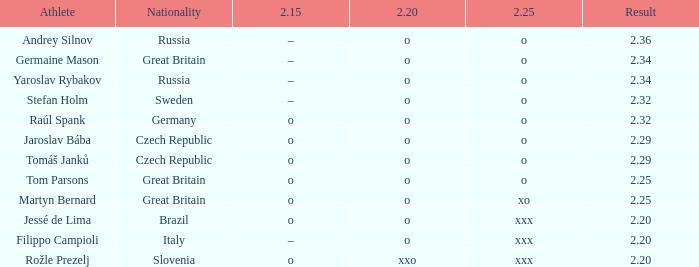20 o and Jessé de Lima. 